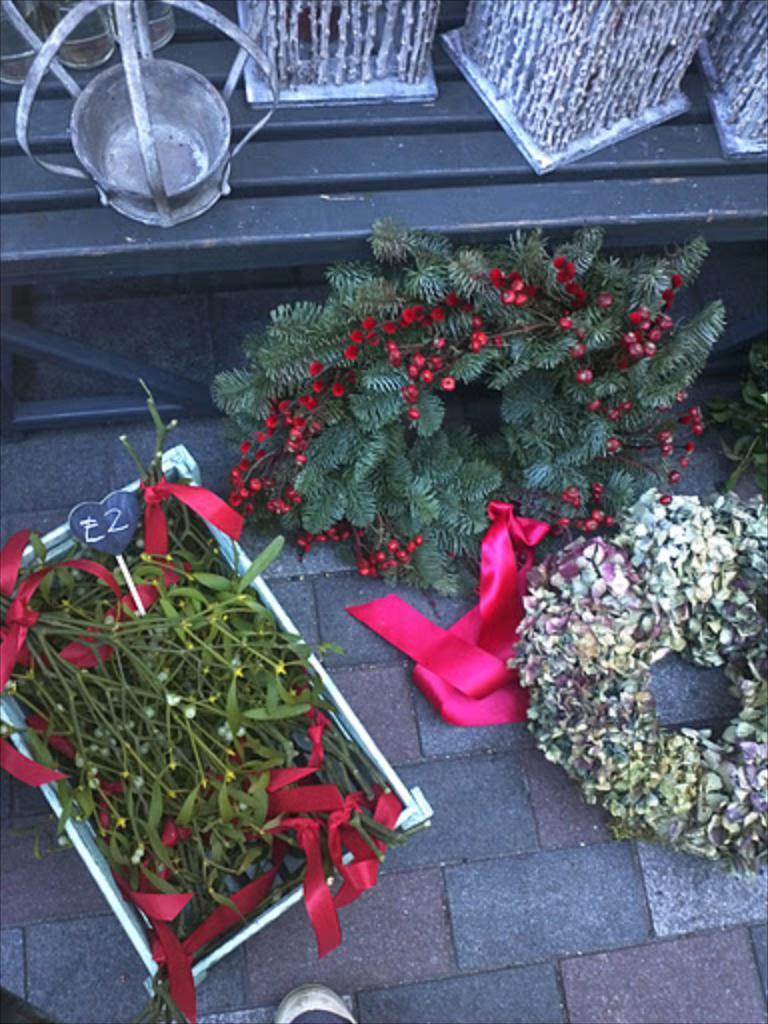How would you summarize this image in a sentence or two? In the picture we can see a path on it we can see a box with leaves in it with some pieces of ribbons in it and beside it we can see some decorative plants and behind it we can see a wall which is black in color on it we can see some decorative items. 